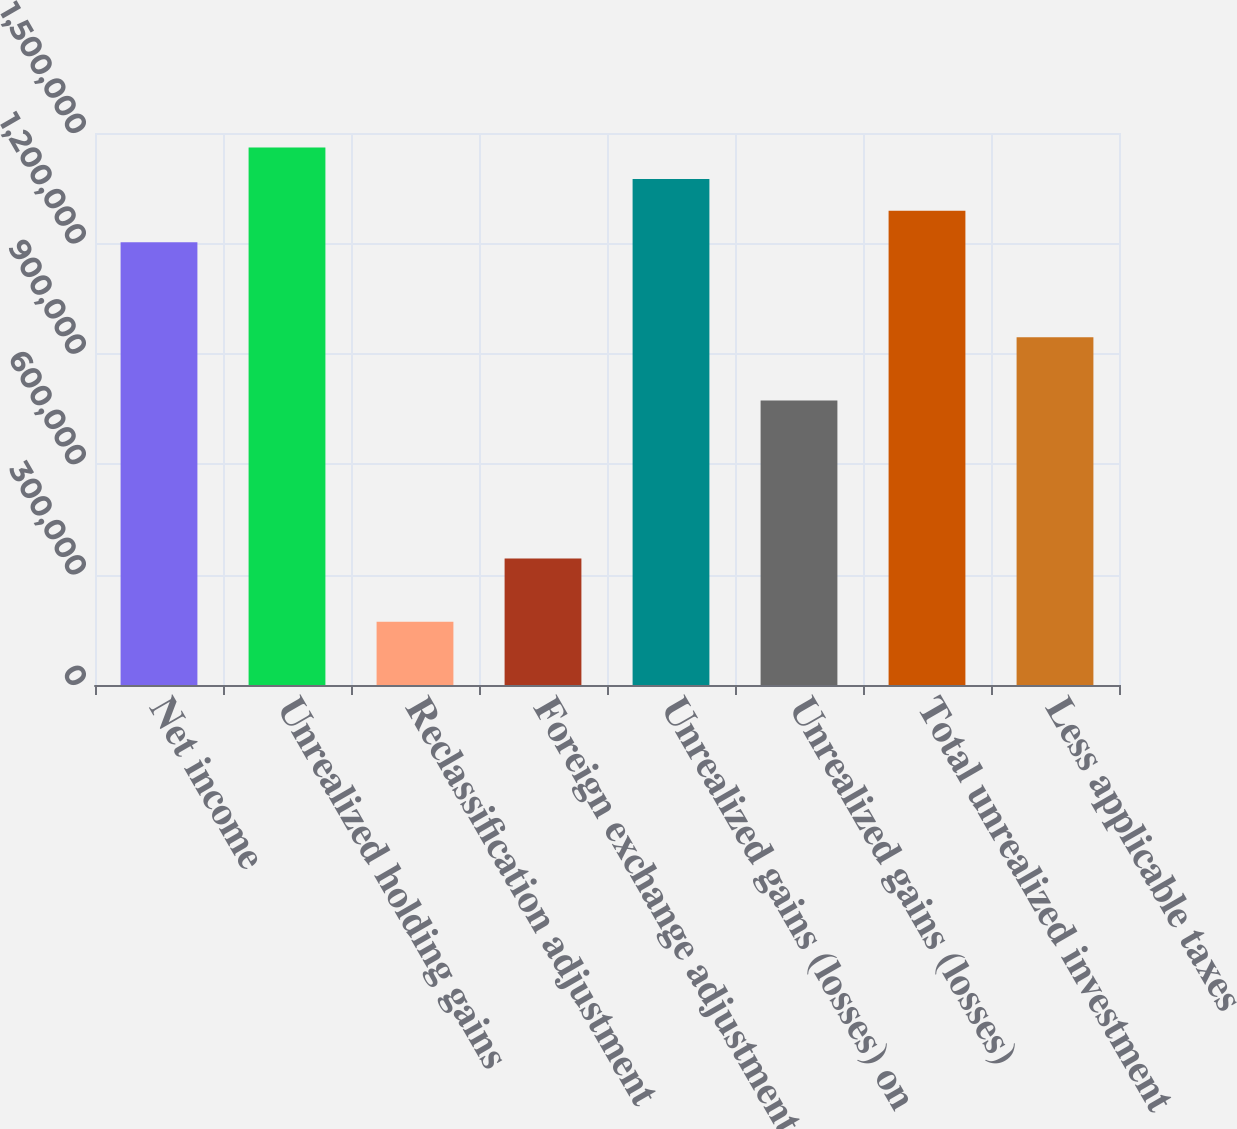Convert chart. <chart><loc_0><loc_0><loc_500><loc_500><bar_chart><fcel>Net income<fcel>Unrealized holding gains<fcel>Reclassification adjustment<fcel>Foreign exchange adjustment on<fcel>Unrealized gains (losses) on<fcel>Unrealized gains (losses)<fcel>Total unrealized investment<fcel>Less applicable taxes<nl><fcel>1.20289e+06<fcel>1.46065e+06<fcel>171843<fcel>343684<fcel>1.37473e+06<fcel>773285<fcel>1.28881e+06<fcel>945125<nl></chart> 